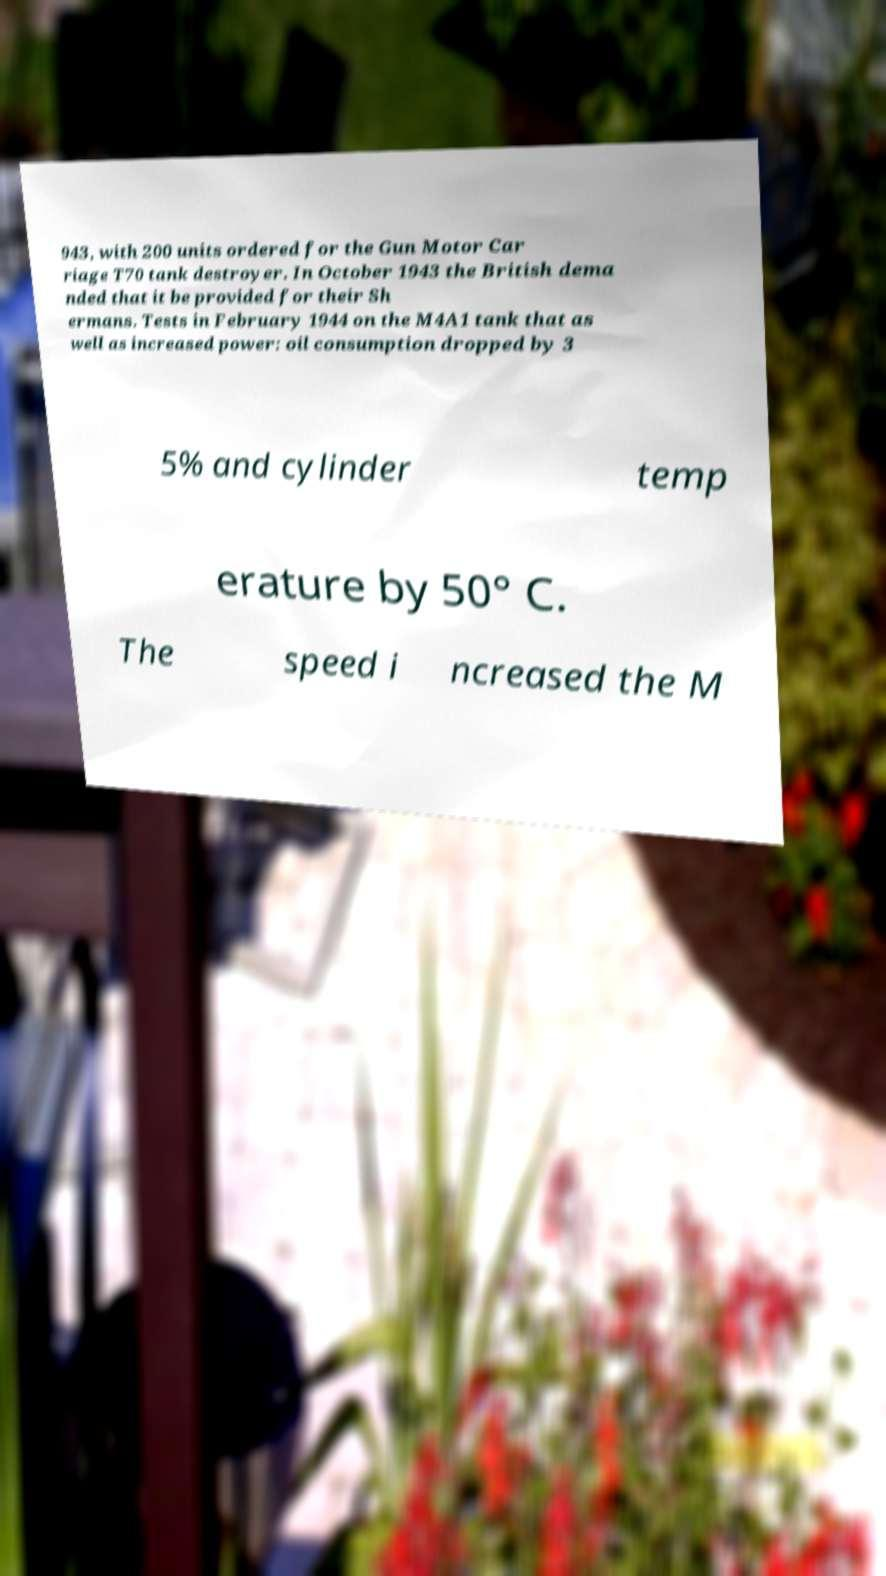There's text embedded in this image that I need extracted. Can you transcribe it verbatim? 943, with 200 units ordered for the Gun Motor Car riage T70 tank destroyer. In October 1943 the British dema nded that it be provided for their Sh ermans. Tests in February 1944 on the M4A1 tank that as well as increased power: oil consumption dropped by 3 5% and cylinder temp erature by 50° C. The speed i ncreased the M 